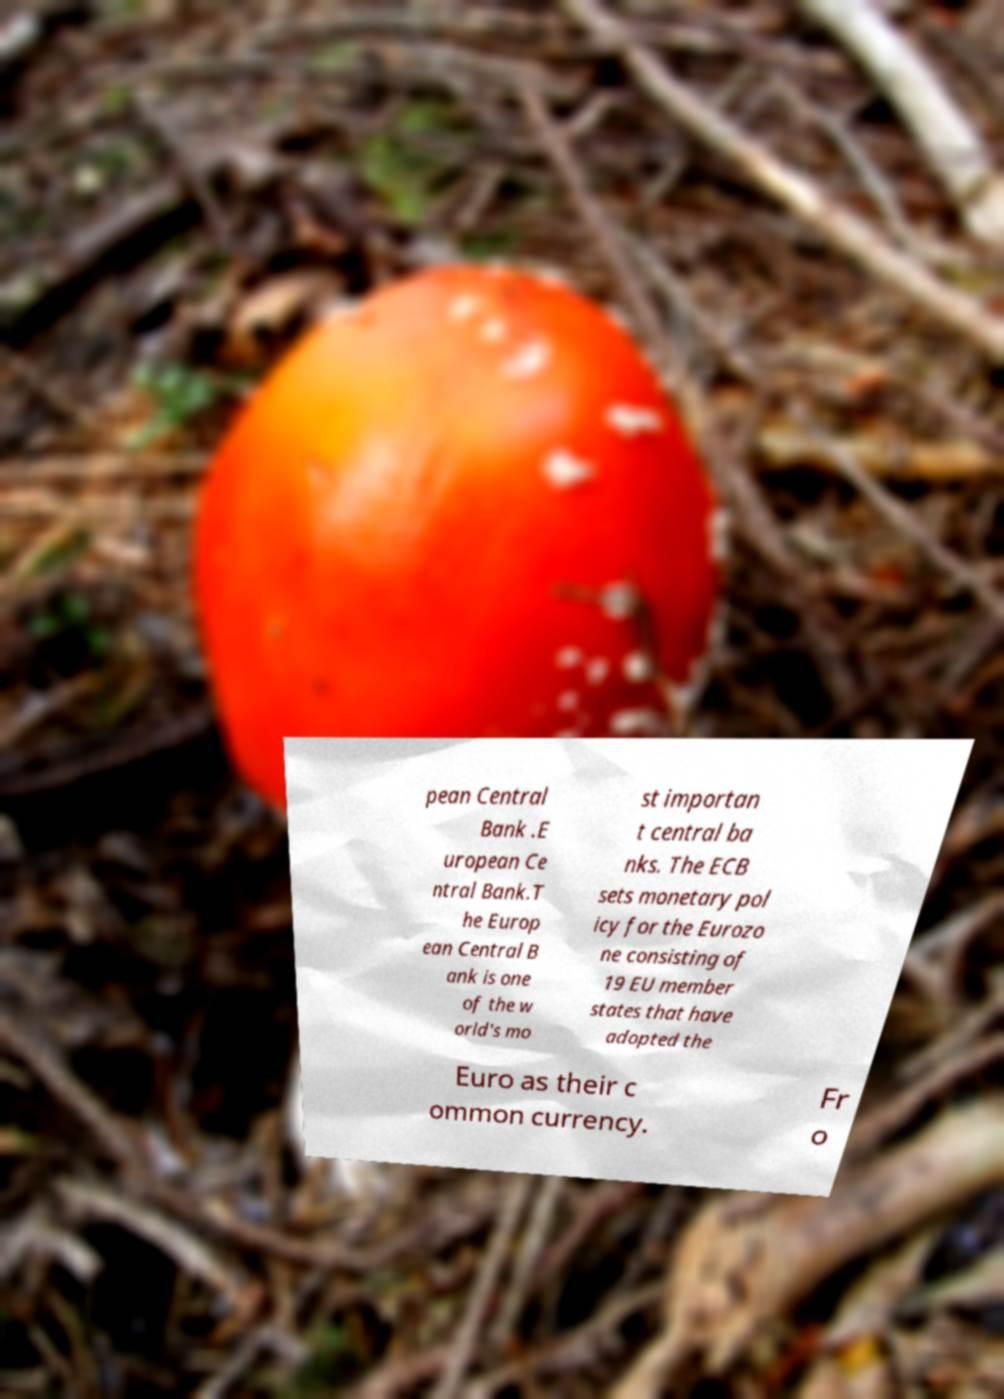There's text embedded in this image that I need extracted. Can you transcribe it verbatim? pean Central Bank .E uropean Ce ntral Bank.T he Europ ean Central B ank is one of the w orld's mo st importan t central ba nks. The ECB sets monetary pol icy for the Eurozo ne consisting of 19 EU member states that have adopted the Euro as their c ommon currency. Fr o 